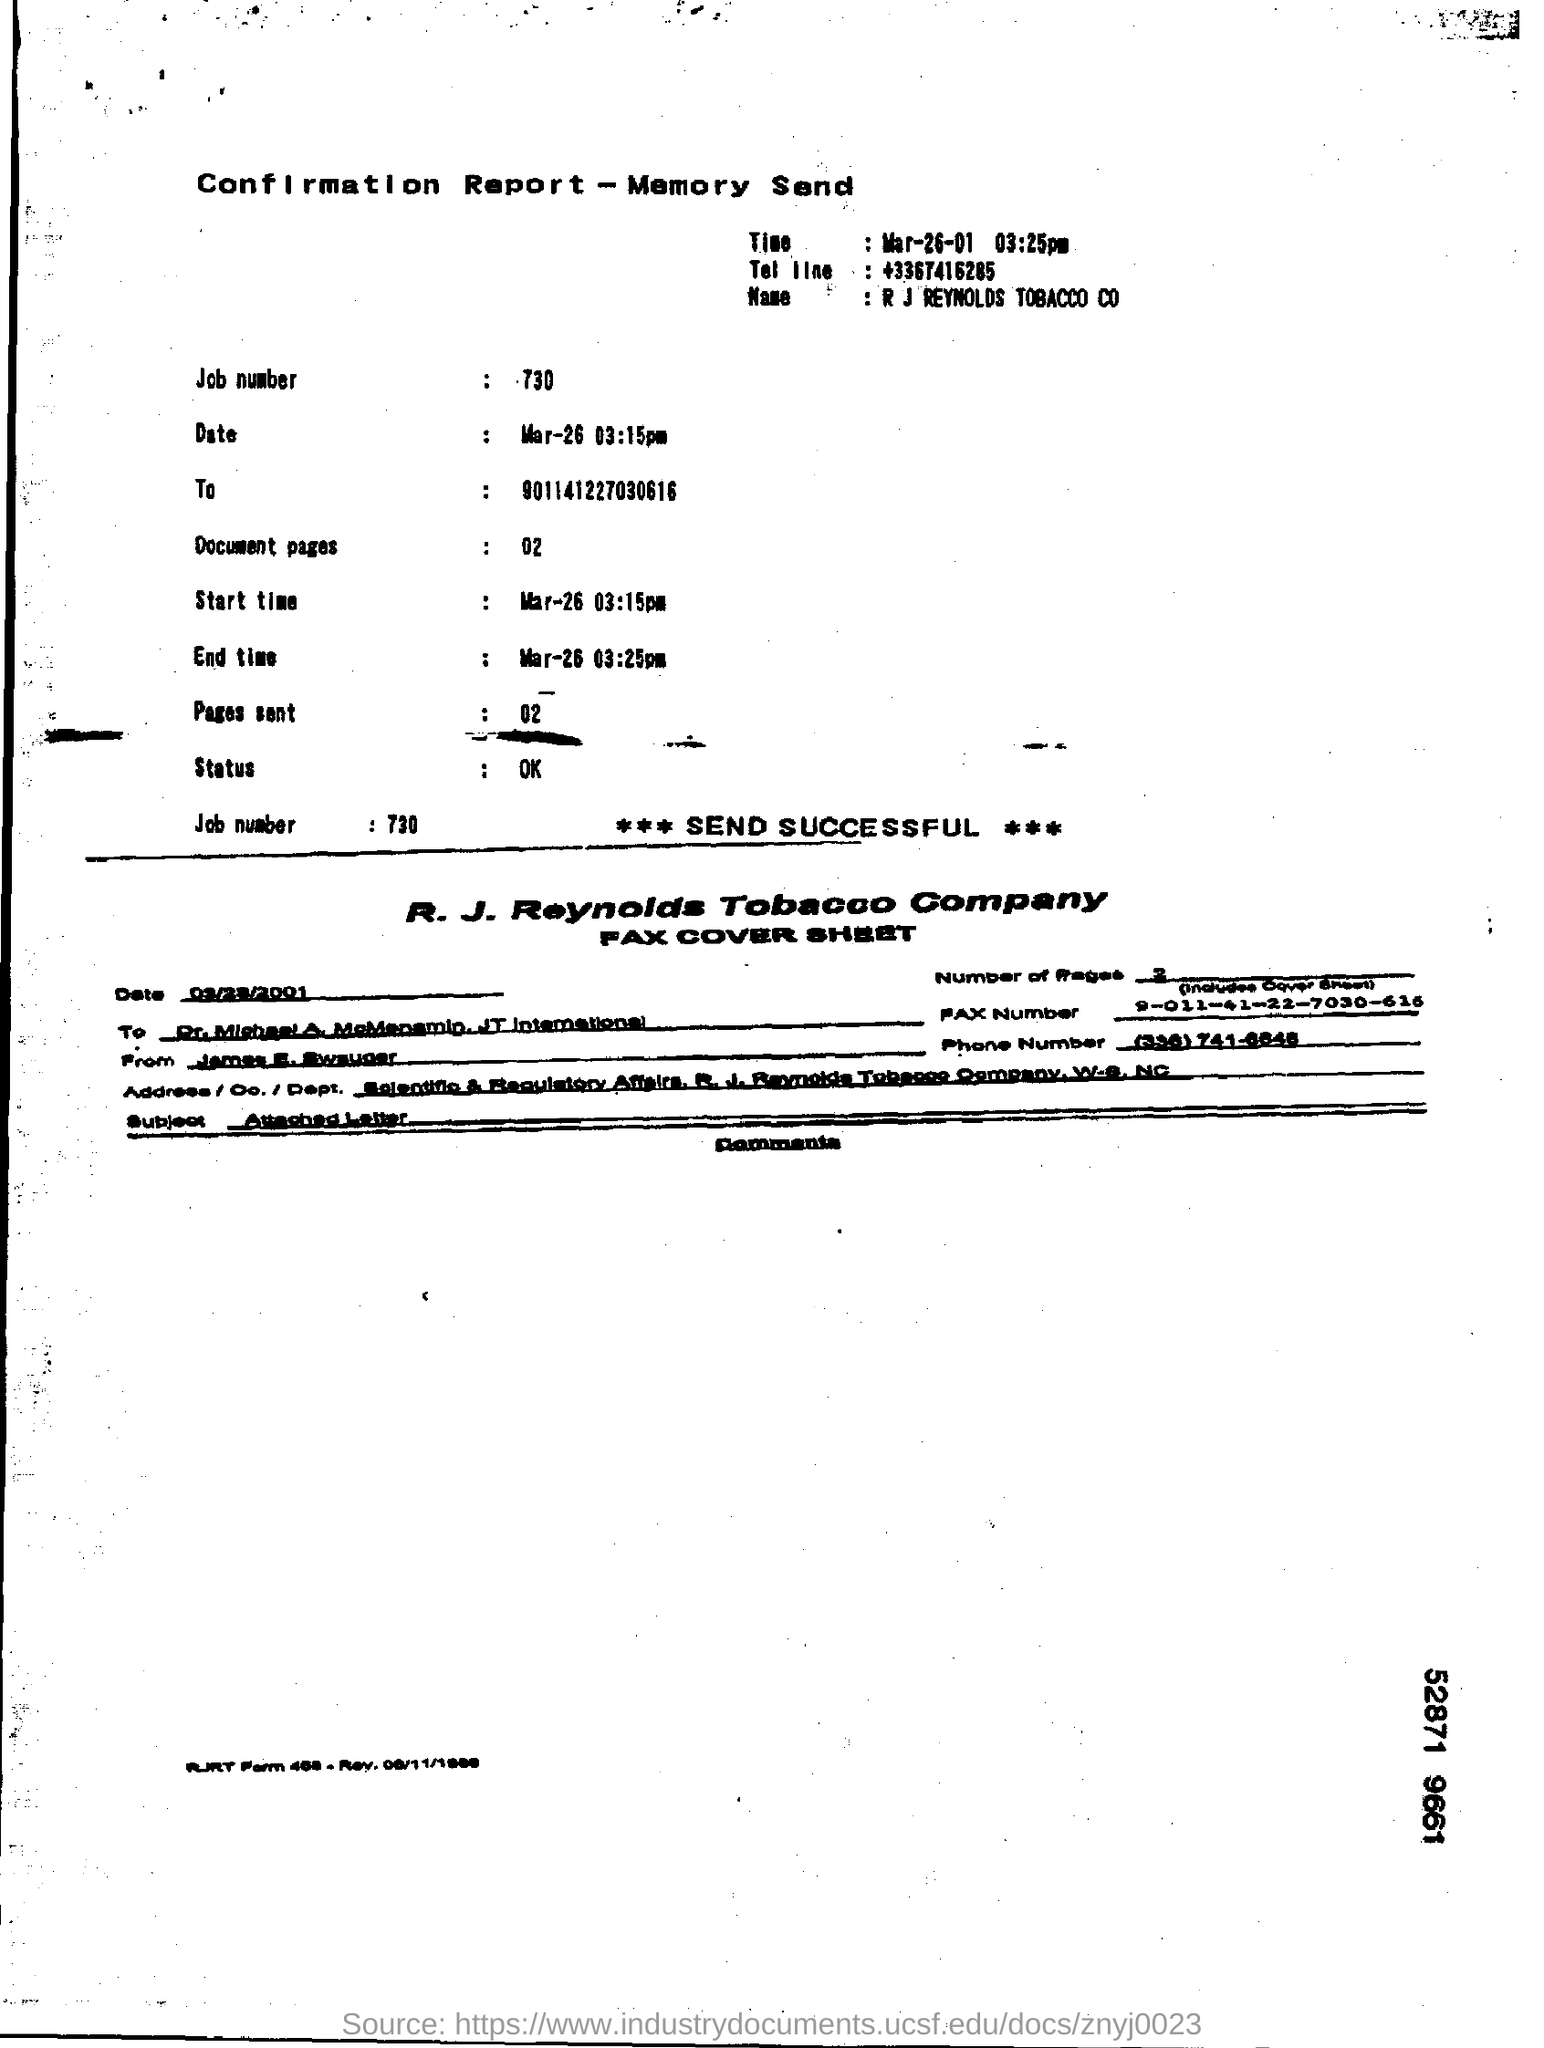WHAT IS THE JOB NUMBER?
Provide a short and direct response. 730. WHAT IS THE NAME OF THE COMPANY?
Offer a very short reply. R. J. Reynolds tobacco company. WHAT IS THE TEPHONE NUMBER MENTIONED?
Offer a terse response. +3367416285. WHAT REPORT IS IT?
Offer a terse response. Confirmation Report. 